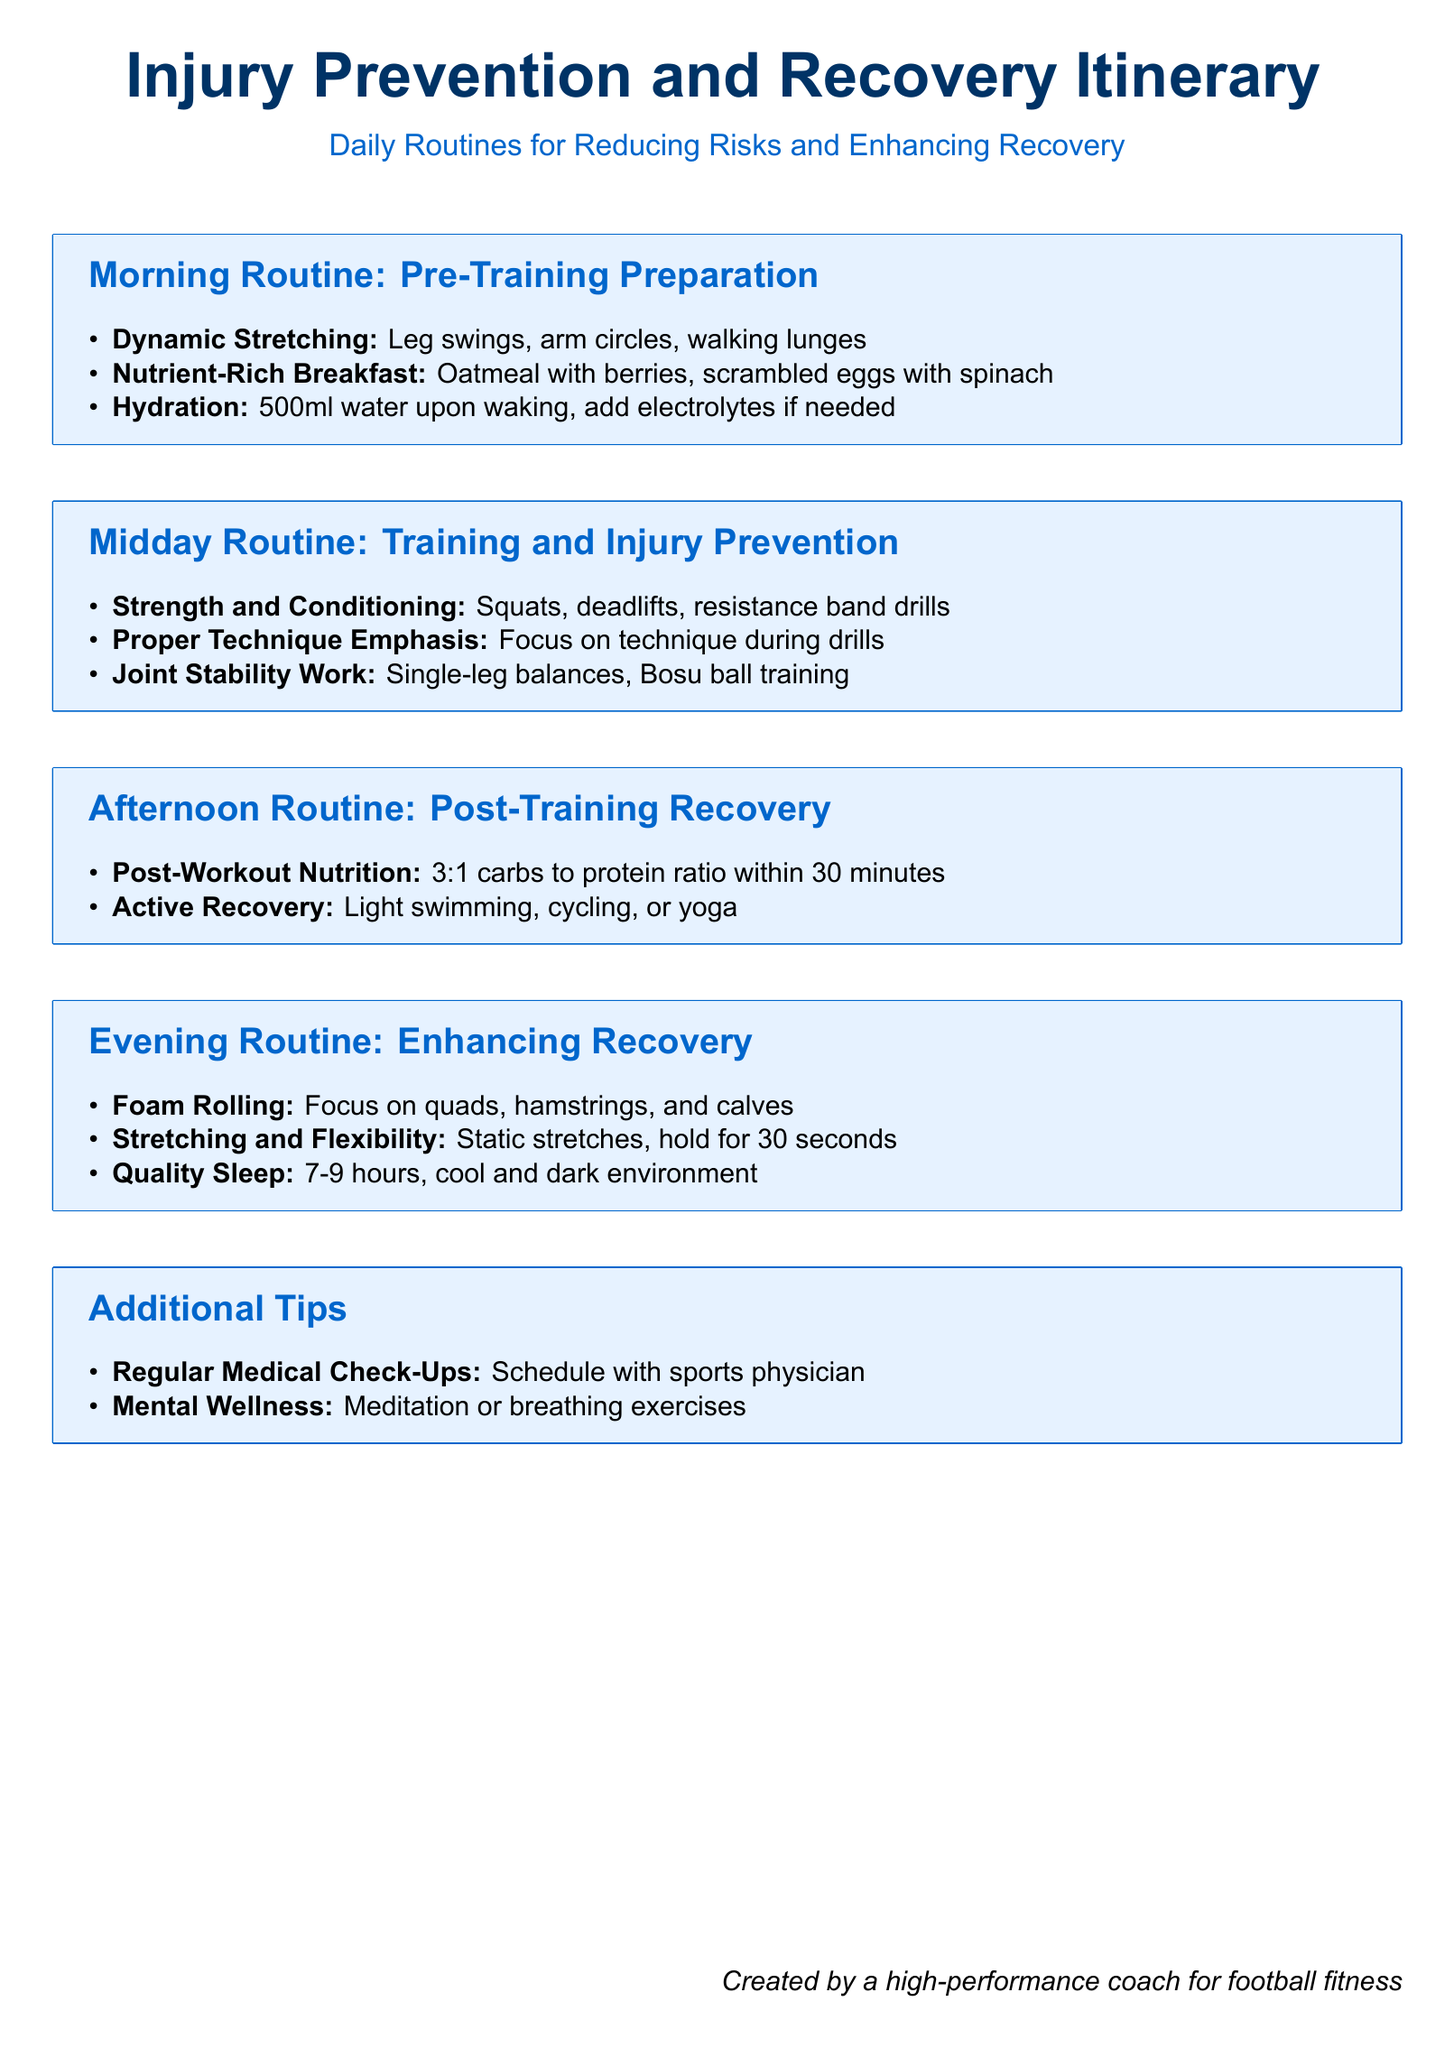What is included in the morning routine? The morning routine lists dynamic stretching, nutrient-rich breakfast, and hydration.
Answer: Dynamic stretching, nutrient-rich breakfast, hydration What type of breakfast is suggested? The document specifies oatmeal with berries and scrambled eggs with spinach as breakfast options.
Answer: Oatmeal with berries, scrambled eggs with spinach What exercise is emphasized for joint stability? Joint stability work includes single-leg balances and Bosu ball training.
Answer: Single-leg balances, Bosu ball training What is the recommended post-workout nutrition ratio? The document states a 3:1 carbs to protein ratio within 30 minutes post-workout.
Answer: 3:1 How many hours of sleep are recommended for quality recovery? The document suggests 7-9 hours of sleep for recovery.
Answer: 7-9 hours What kind of recovery activity is suggested for the afternoon routine? Active recovery activities mentioned include light swimming, cycling, or yoga.
Answer: Light swimming, cycling, or yoga What are the additional tips mentioned in the document? The additional tips include regular medical check-ups and mental wellness practices.
Answer: Regular medical check-ups, mental wellness What color is used for section headings? The section headings are in a publicly defined RGB color format.
Answer: RGB(0,102,204) What is the primary focus of this itinerary? The primary focus is on reducing injury risks and enhancing recovery in athletes.
Answer: Reducing risks and enhancing recovery 